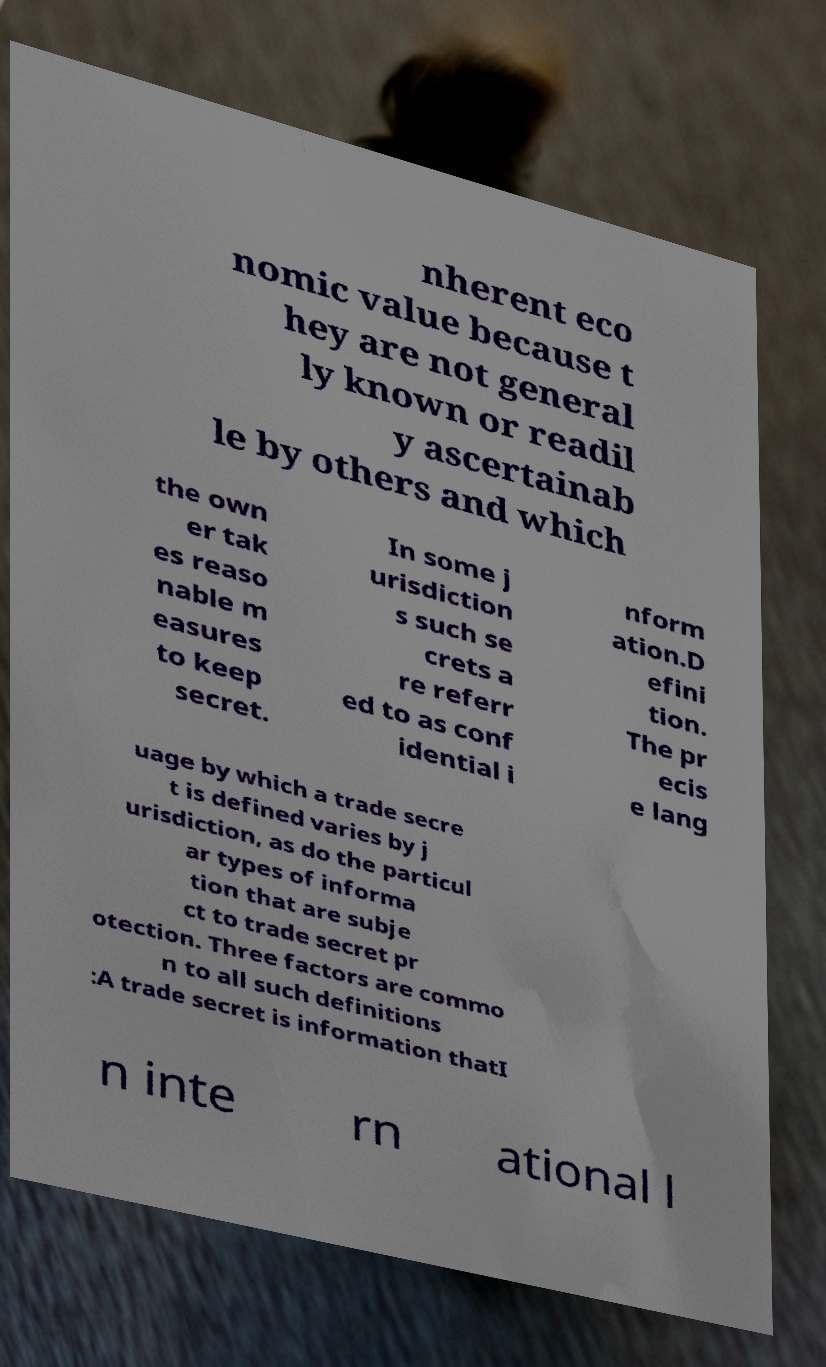Could you assist in decoding the text presented in this image and type it out clearly? nherent eco nomic value because t hey are not general ly known or readil y ascertainab le by others and which the own er tak es reaso nable m easures to keep secret. In some j urisdiction s such se crets a re referr ed to as conf idential i nform ation.D efini tion. The pr ecis e lang uage by which a trade secre t is defined varies by j urisdiction, as do the particul ar types of informa tion that are subje ct to trade secret pr otection. Three factors are commo n to all such definitions :A trade secret is information thatI n inte rn ational l 